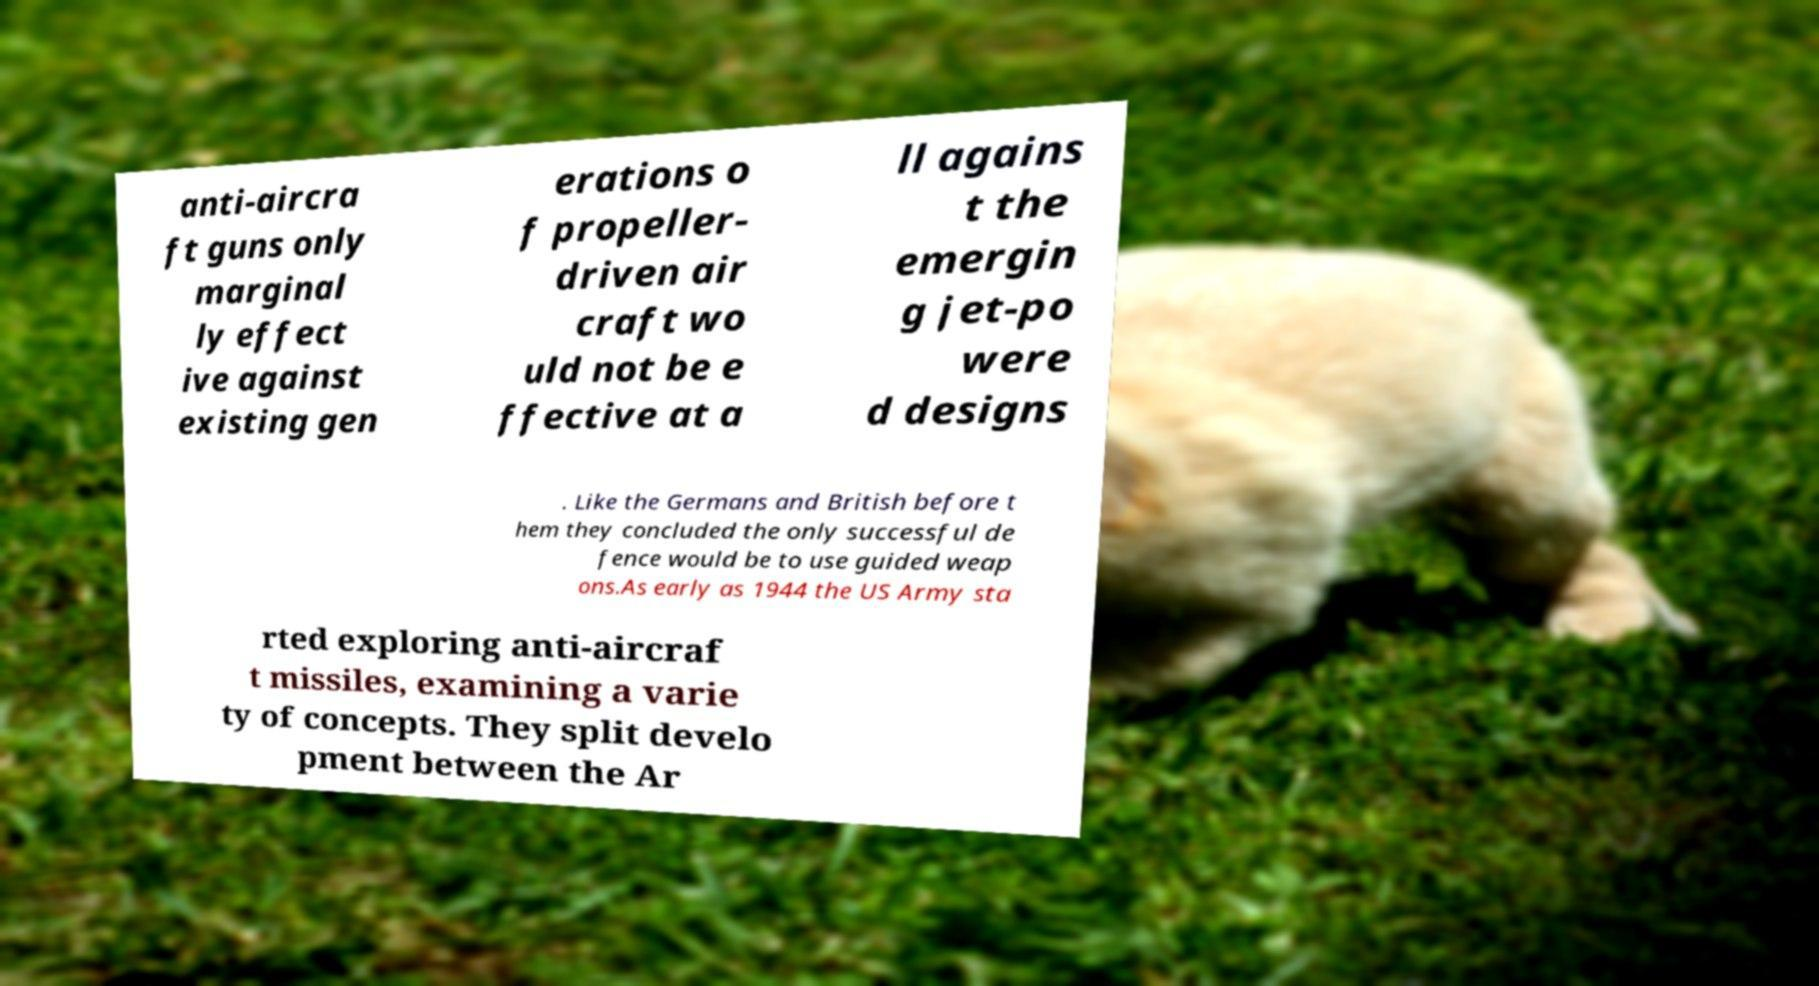What messages or text are displayed in this image? I need them in a readable, typed format. anti-aircra ft guns only marginal ly effect ive against existing gen erations o f propeller- driven air craft wo uld not be e ffective at a ll agains t the emergin g jet-po were d designs . Like the Germans and British before t hem they concluded the only successful de fence would be to use guided weap ons.As early as 1944 the US Army sta rted exploring anti-aircraf t missiles, examining a varie ty of concepts. They split develo pment between the Ar 